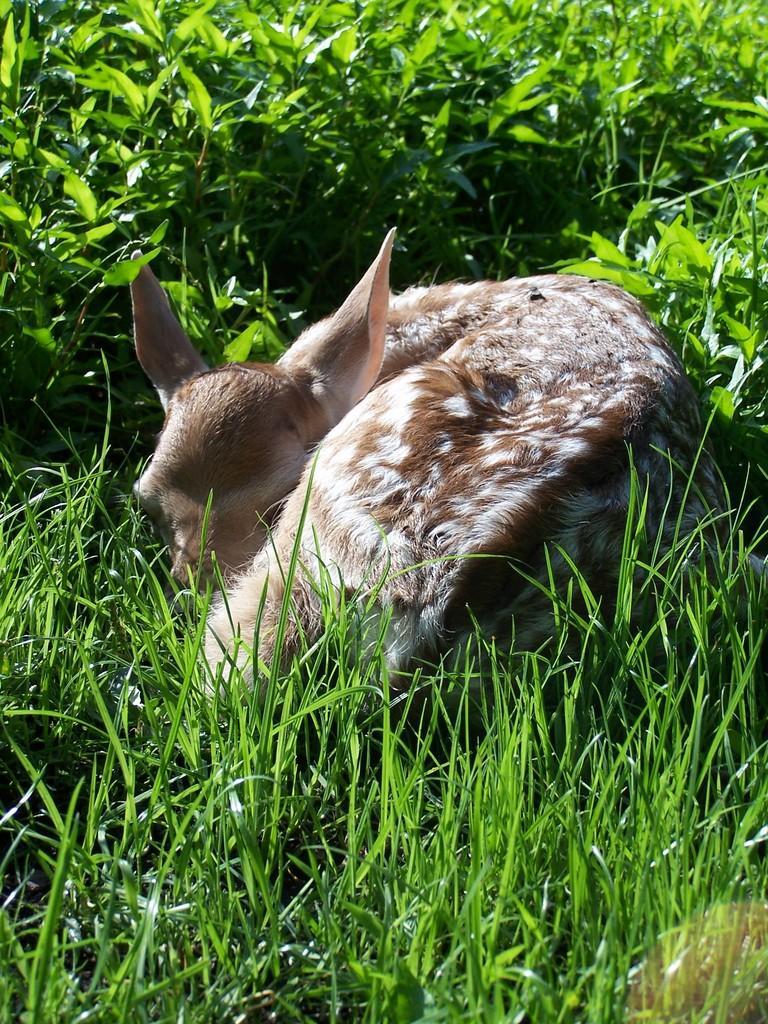Could you give a brief overview of what you see in this image? In this picture we can see an animal on the grass and plants. 